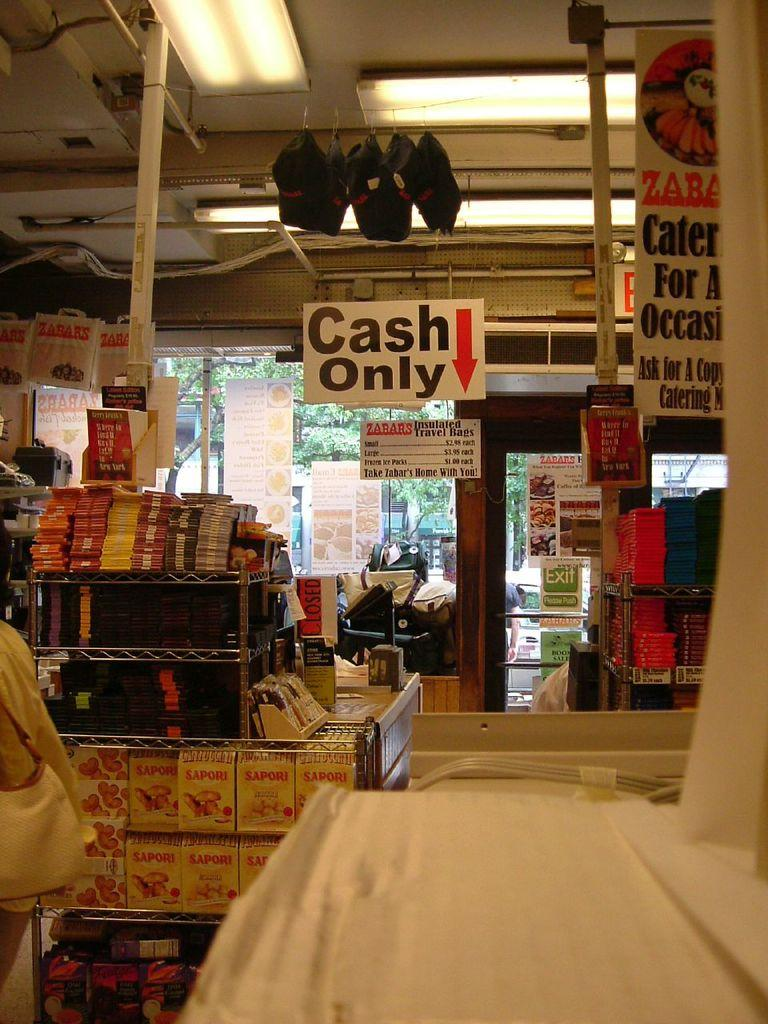<image>
Relay a brief, clear account of the picture shown. Store very packed with goods and sign "Cash Only" up above 